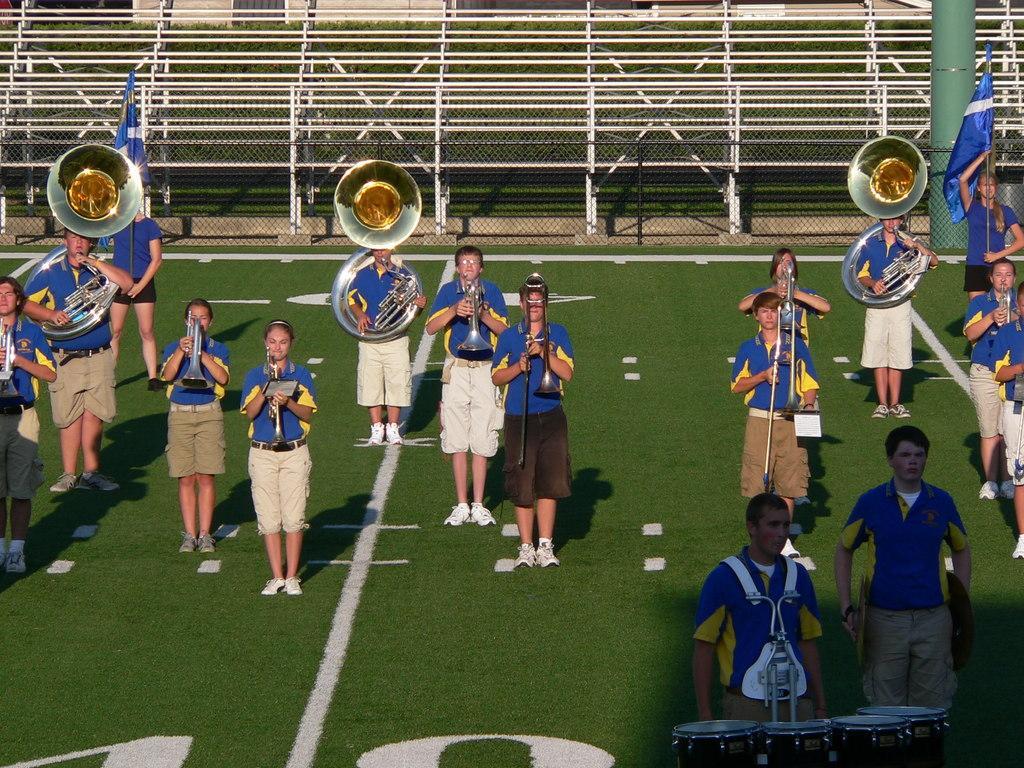How would you summarize this image in a sentence or two? As we can see in the image, there are group of people standing and playing musical instruments and the women on the right side is holding blue color flag. 